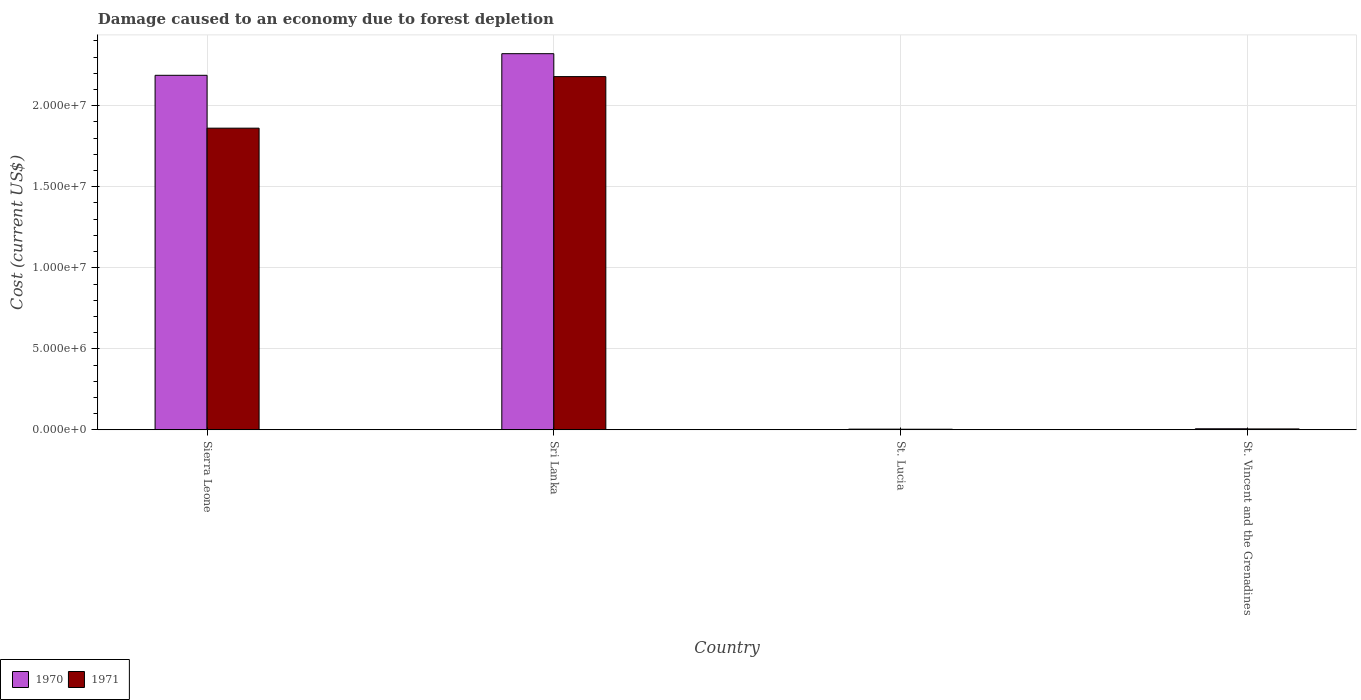How many groups of bars are there?
Provide a succinct answer. 4. Are the number of bars on each tick of the X-axis equal?
Keep it short and to the point. Yes. How many bars are there on the 2nd tick from the left?
Keep it short and to the point. 2. How many bars are there on the 4th tick from the right?
Offer a terse response. 2. What is the label of the 2nd group of bars from the left?
Give a very brief answer. Sri Lanka. In how many cases, is the number of bars for a given country not equal to the number of legend labels?
Your response must be concise. 0. What is the cost of damage caused due to forest depletion in 1970 in Sri Lanka?
Provide a short and direct response. 2.32e+07. Across all countries, what is the maximum cost of damage caused due to forest depletion in 1971?
Make the answer very short. 2.18e+07. Across all countries, what is the minimum cost of damage caused due to forest depletion in 1970?
Offer a terse response. 4.11e+04. In which country was the cost of damage caused due to forest depletion in 1971 maximum?
Ensure brevity in your answer.  Sri Lanka. In which country was the cost of damage caused due to forest depletion in 1970 minimum?
Your answer should be very brief. St. Lucia. What is the total cost of damage caused due to forest depletion in 1970 in the graph?
Give a very brief answer. 4.52e+07. What is the difference between the cost of damage caused due to forest depletion in 1971 in St. Lucia and that in St. Vincent and the Grenadines?
Your answer should be very brief. -1.84e+04. What is the difference between the cost of damage caused due to forest depletion in 1970 in St. Lucia and the cost of damage caused due to forest depletion in 1971 in St. Vincent and the Grenadines?
Your answer should be compact. -1.30e+04. What is the average cost of damage caused due to forest depletion in 1971 per country?
Give a very brief answer. 1.01e+07. What is the difference between the cost of damage caused due to forest depletion of/in 1971 and cost of damage caused due to forest depletion of/in 1970 in Sierra Leone?
Your answer should be very brief. -3.26e+06. What is the ratio of the cost of damage caused due to forest depletion in 1971 in Sierra Leone to that in St. Lucia?
Give a very brief answer. 520.23. What is the difference between the highest and the second highest cost of damage caused due to forest depletion in 1971?
Give a very brief answer. -2.17e+07. What is the difference between the highest and the lowest cost of damage caused due to forest depletion in 1971?
Your answer should be very brief. 2.18e+07. In how many countries, is the cost of damage caused due to forest depletion in 1970 greater than the average cost of damage caused due to forest depletion in 1970 taken over all countries?
Offer a very short reply. 2. What does the 2nd bar from the left in St. Lucia represents?
Your answer should be very brief. 1971. Are all the bars in the graph horizontal?
Your answer should be compact. No. How many countries are there in the graph?
Offer a terse response. 4. Does the graph contain grids?
Offer a terse response. Yes. Where does the legend appear in the graph?
Provide a succinct answer. Bottom left. What is the title of the graph?
Make the answer very short. Damage caused to an economy due to forest depletion. Does "1982" appear as one of the legend labels in the graph?
Offer a very short reply. No. What is the label or title of the X-axis?
Your response must be concise. Country. What is the label or title of the Y-axis?
Make the answer very short. Cost (current US$). What is the Cost (current US$) of 1970 in Sierra Leone?
Your answer should be compact. 2.19e+07. What is the Cost (current US$) in 1971 in Sierra Leone?
Your response must be concise. 1.86e+07. What is the Cost (current US$) in 1970 in Sri Lanka?
Your response must be concise. 2.32e+07. What is the Cost (current US$) in 1971 in Sri Lanka?
Give a very brief answer. 2.18e+07. What is the Cost (current US$) of 1970 in St. Lucia?
Provide a succinct answer. 4.11e+04. What is the Cost (current US$) of 1971 in St. Lucia?
Your answer should be very brief. 3.58e+04. What is the Cost (current US$) in 1970 in St. Vincent and the Grenadines?
Offer a very short reply. 6.39e+04. What is the Cost (current US$) of 1971 in St. Vincent and the Grenadines?
Ensure brevity in your answer.  5.42e+04. Across all countries, what is the maximum Cost (current US$) in 1970?
Offer a very short reply. 2.32e+07. Across all countries, what is the maximum Cost (current US$) in 1971?
Provide a short and direct response. 2.18e+07. Across all countries, what is the minimum Cost (current US$) in 1970?
Ensure brevity in your answer.  4.11e+04. Across all countries, what is the minimum Cost (current US$) of 1971?
Your response must be concise. 3.58e+04. What is the total Cost (current US$) of 1970 in the graph?
Your response must be concise. 4.52e+07. What is the total Cost (current US$) in 1971 in the graph?
Provide a succinct answer. 4.05e+07. What is the difference between the Cost (current US$) in 1970 in Sierra Leone and that in Sri Lanka?
Provide a short and direct response. -1.34e+06. What is the difference between the Cost (current US$) of 1971 in Sierra Leone and that in Sri Lanka?
Offer a terse response. -3.18e+06. What is the difference between the Cost (current US$) in 1970 in Sierra Leone and that in St. Lucia?
Offer a terse response. 2.18e+07. What is the difference between the Cost (current US$) in 1971 in Sierra Leone and that in St. Lucia?
Give a very brief answer. 1.86e+07. What is the difference between the Cost (current US$) of 1970 in Sierra Leone and that in St. Vincent and the Grenadines?
Your answer should be compact. 2.18e+07. What is the difference between the Cost (current US$) in 1971 in Sierra Leone and that in St. Vincent and the Grenadines?
Offer a very short reply. 1.86e+07. What is the difference between the Cost (current US$) in 1970 in Sri Lanka and that in St. Lucia?
Provide a short and direct response. 2.32e+07. What is the difference between the Cost (current US$) of 1971 in Sri Lanka and that in St. Lucia?
Your answer should be compact. 2.18e+07. What is the difference between the Cost (current US$) of 1970 in Sri Lanka and that in St. Vincent and the Grenadines?
Keep it short and to the point. 2.32e+07. What is the difference between the Cost (current US$) in 1971 in Sri Lanka and that in St. Vincent and the Grenadines?
Ensure brevity in your answer.  2.17e+07. What is the difference between the Cost (current US$) of 1970 in St. Lucia and that in St. Vincent and the Grenadines?
Your response must be concise. -2.28e+04. What is the difference between the Cost (current US$) in 1971 in St. Lucia and that in St. Vincent and the Grenadines?
Provide a short and direct response. -1.84e+04. What is the difference between the Cost (current US$) of 1970 in Sierra Leone and the Cost (current US$) of 1971 in Sri Lanka?
Offer a terse response. 8.01e+04. What is the difference between the Cost (current US$) of 1970 in Sierra Leone and the Cost (current US$) of 1971 in St. Lucia?
Offer a terse response. 2.18e+07. What is the difference between the Cost (current US$) of 1970 in Sierra Leone and the Cost (current US$) of 1971 in St. Vincent and the Grenadines?
Your answer should be very brief. 2.18e+07. What is the difference between the Cost (current US$) of 1970 in Sri Lanka and the Cost (current US$) of 1971 in St. Lucia?
Your response must be concise. 2.32e+07. What is the difference between the Cost (current US$) of 1970 in Sri Lanka and the Cost (current US$) of 1971 in St. Vincent and the Grenadines?
Your response must be concise. 2.32e+07. What is the difference between the Cost (current US$) of 1970 in St. Lucia and the Cost (current US$) of 1971 in St. Vincent and the Grenadines?
Provide a short and direct response. -1.30e+04. What is the average Cost (current US$) in 1970 per country?
Your answer should be very brief. 1.13e+07. What is the average Cost (current US$) in 1971 per country?
Offer a terse response. 1.01e+07. What is the difference between the Cost (current US$) in 1970 and Cost (current US$) in 1971 in Sierra Leone?
Offer a terse response. 3.26e+06. What is the difference between the Cost (current US$) in 1970 and Cost (current US$) in 1971 in Sri Lanka?
Give a very brief answer. 1.42e+06. What is the difference between the Cost (current US$) in 1970 and Cost (current US$) in 1971 in St. Lucia?
Provide a succinct answer. 5318.94. What is the difference between the Cost (current US$) of 1970 and Cost (current US$) of 1971 in St. Vincent and the Grenadines?
Your answer should be very brief. 9736.92. What is the ratio of the Cost (current US$) in 1970 in Sierra Leone to that in Sri Lanka?
Ensure brevity in your answer.  0.94. What is the ratio of the Cost (current US$) in 1971 in Sierra Leone to that in Sri Lanka?
Offer a terse response. 0.85. What is the ratio of the Cost (current US$) of 1970 in Sierra Leone to that in St. Lucia?
Give a very brief answer. 532.27. What is the ratio of the Cost (current US$) of 1971 in Sierra Leone to that in St. Lucia?
Provide a short and direct response. 520.23. What is the ratio of the Cost (current US$) of 1970 in Sierra Leone to that in St. Vincent and the Grenadines?
Ensure brevity in your answer.  342.47. What is the ratio of the Cost (current US$) in 1971 in Sierra Leone to that in St. Vincent and the Grenadines?
Provide a short and direct response. 343.81. What is the ratio of the Cost (current US$) of 1970 in Sri Lanka to that in St. Lucia?
Your answer should be very brief. 564.74. What is the ratio of the Cost (current US$) of 1971 in Sri Lanka to that in St. Lucia?
Ensure brevity in your answer.  609.13. What is the ratio of the Cost (current US$) of 1970 in Sri Lanka to that in St. Vincent and the Grenadines?
Ensure brevity in your answer.  363.37. What is the ratio of the Cost (current US$) of 1971 in Sri Lanka to that in St. Vincent and the Grenadines?
Provide a succinct answer. 402.56. What is the ratio of the Cost (current US$) of 1970 in St. Lucia to that in St. Vincent and the Grenadines?
Make the answer very short. 0.64. What is the ratio of the Cost (current US$) in 1971 in St. Lucia to that in St. Vincent and the Grenadines?
Provide a short and direct response. 0.66. What is the difference between the highest and the second highest Cost (current US$) in 1970?
Offer a terse response. 1.34e+06. What is the difference between the highest and the second highest Cost (current US$) in 1971?
Offer a very short reply. 3.18e+06. What is the difference between the highest and the lowest Cost (current US$) of 1970?
Provide a short and direct response. 2.32e+07. What is the difference between the highest and the lowest Cost (current US$) of 1971?
Offer a very short reply. 2.18e+07. 